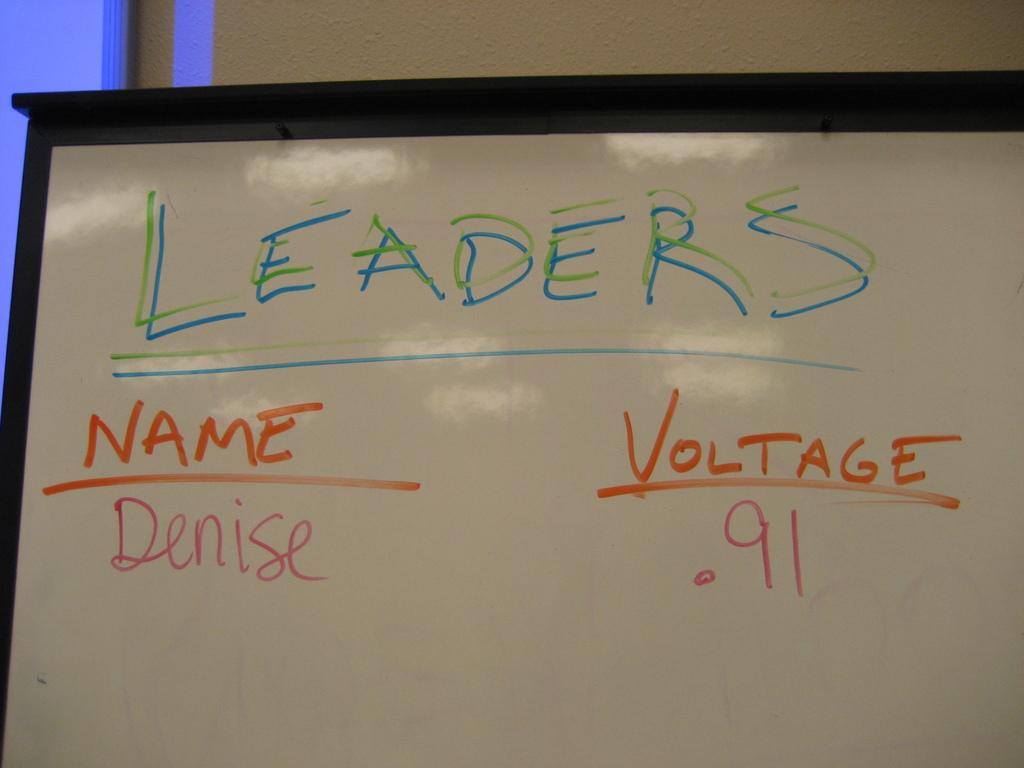How much voltage is there?
Offer a very short reply. .91. Is denise the top leader?
Give a very brief answer. Yes. 